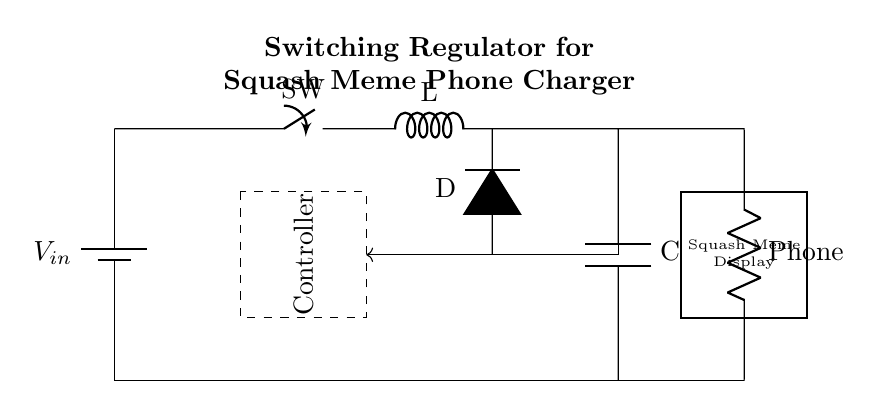What component is used to store energy in this circuit? The inductor is used to store energy in the circuit. It is represented by the letter "L" in the circuit diagram, indicating its function as an energy storage element.
Answer: Inductor What is the purpose of the diode in this circuit? The diode allows current to flow in one direction only, preventing backflow which could potentially damage the components or disrupt the charging of the phone. In this case, it is labeled as "D".
Answer: Prevent backflow What does the feedback loop achieve in this circuit? The feedback loop helps regulate output voltage by comparing the output voltage with a reference voltage provided by the controller, ensuring consistent charging characteristics for the smartphone. This is indicated by the arrow leading from the output to the controller.
Answer: Regulate output voltage What type of circuit is this? This is a switching regulator circuit, which is designed to efficiently convert input voltage to a stable output voltage for charging devices. The rapid switching of the switch component allows for energy control and regulation.
Answer: Switching regulator What does the component labeled "Phone" represent? The component labeled as "Phone" represents the load in the circuit, which is the smartphone being charged. It illustrates where the output of the regulator is directed.
Answer: Smartphone What is displayed on the output device of this circuit? The output device, which is a rectangular component labeled "Squash Meme Display", indicates that it displays humorous squash-themed memes, adding a fun aspect to the phone charging experience.
Answer: Squash memes 